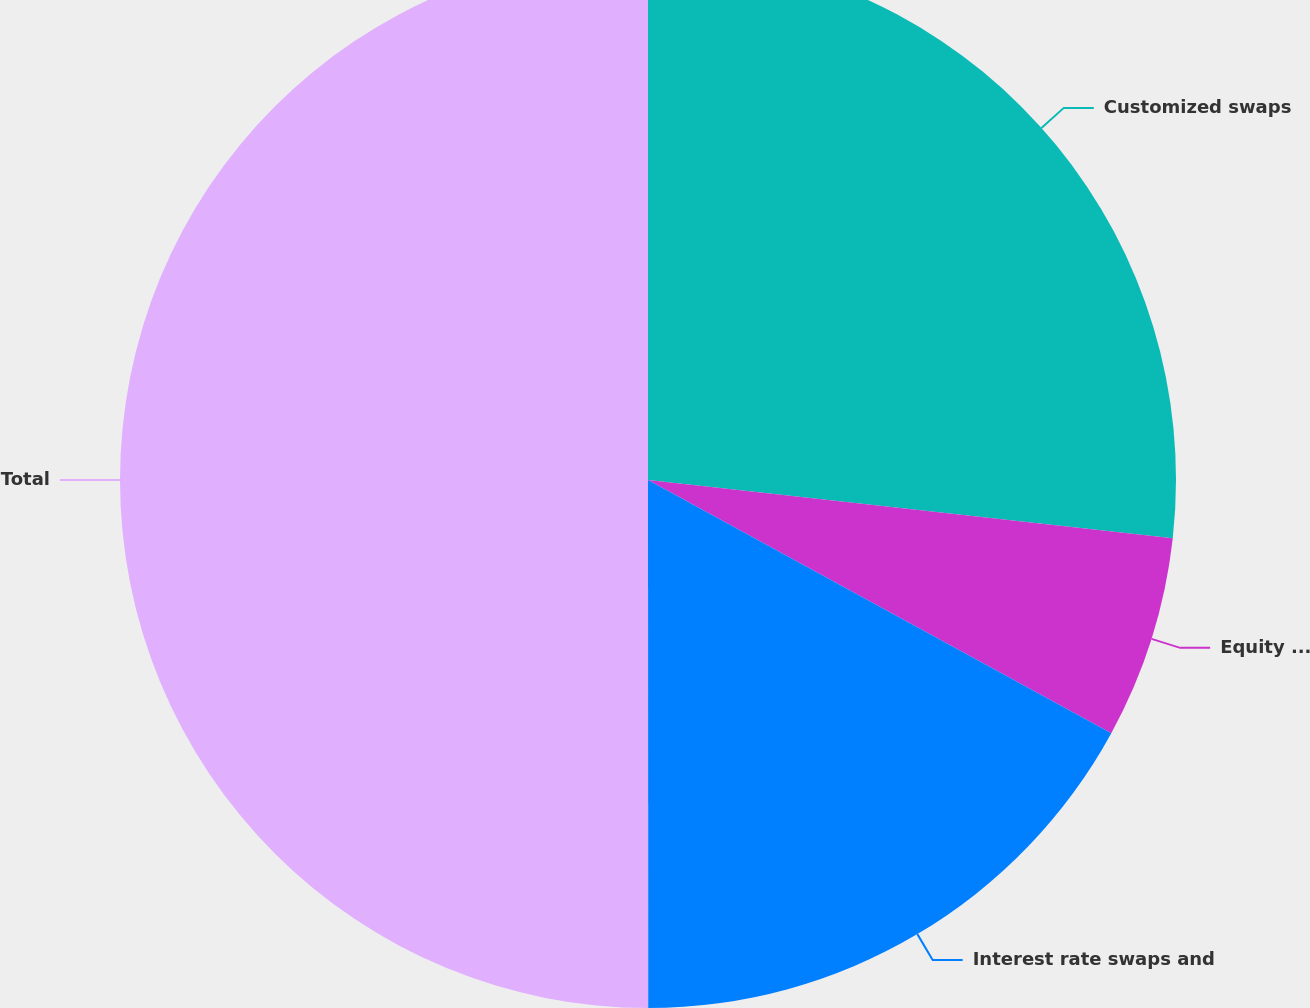Convert chart. <chart><loc_0><loc_0><loc_500><loc_500><pie_chart><fcel>Customized swaps<fcel>Equity swapsoptions and<fcel>Interest rate swaps and<fcel>Total<nl><fcel>26.76%<fcel>6.2%<fcel>17.03%<fcel>50.0%<nl></chart> 